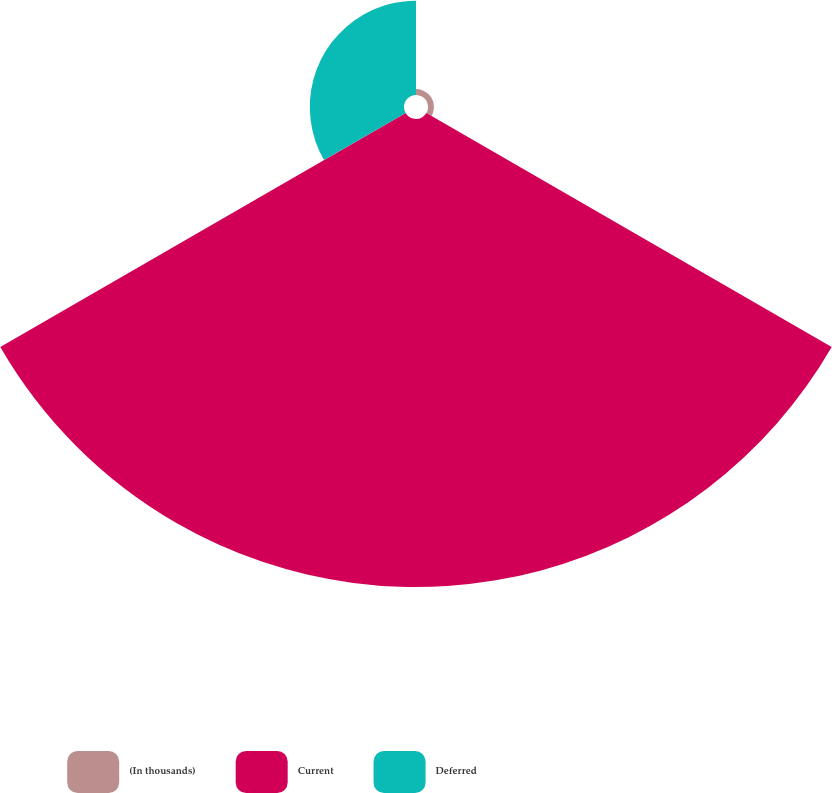Convert chart. <chart><loc_0><loc_0><loc_500><loc_500><pie_chart><fcel>(In thousands)<fcel>Current<fcel>Deferred<nl><fcel>1.05%<fcel>82.37%<fcel>16.58%<nl></chart> 